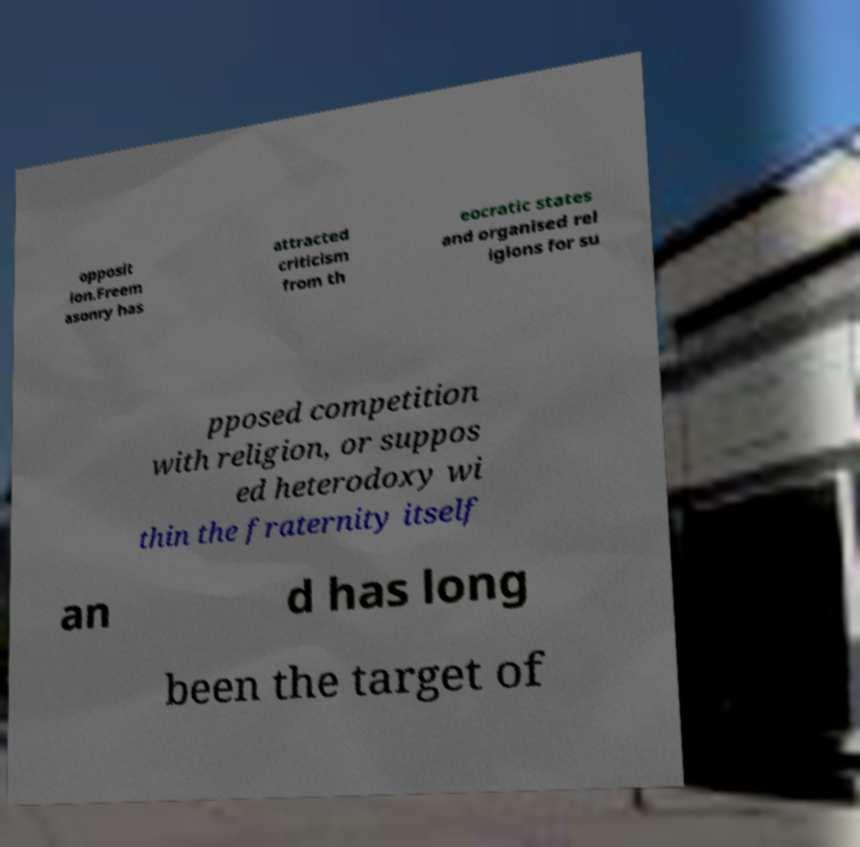For documentation purposes, I need the text within this image transcribed. Could you provide that? opposit ion.Freem asonry has attracted criticism from th eocratic states and organised rel igions for su pposed competition with religion, or suppos ed heterodoxy wi thin the fraternity itself an d has long been the target of 